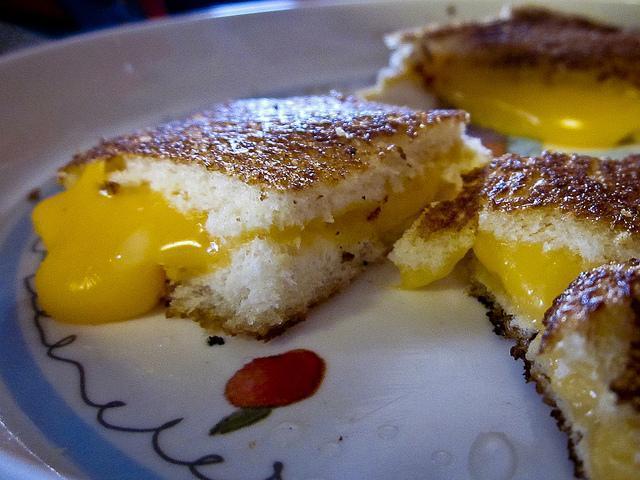How many sandwiches are there?
Give a very brief answer. 3. How many sinks in the room?
Give a very brief answer. 0. 